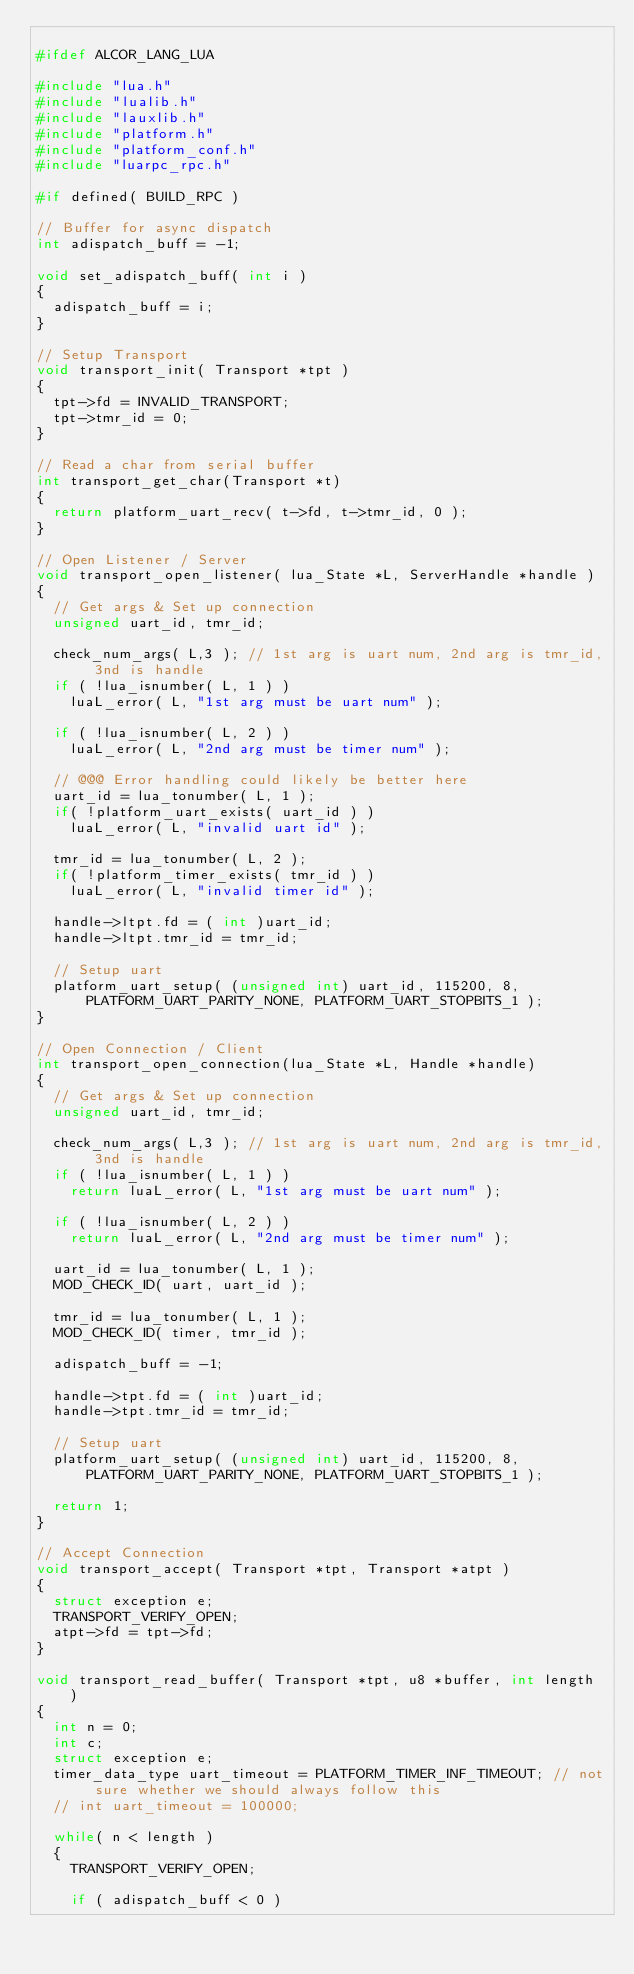Convert code to text. <code><loc_0><loc_0><loc_500><loc_500><_C_>
#ifdef ALCOR_LANG_LUA

#include "lua.h"
#include "lualib.h"
#include "lauxlib.h"
#include "platform.h"
#include "platform_conf.h"
#include "luarpc_rpc.h"

#if defined( BUILD_RPC )

// Buffer for async dispatch
int adispatch_buff = -1;

void set_adispatch_buff( int i )
{
  adispatch_buff = i;
}

// Setup Transport
void transport_init( Transport *tpt )
{
  tpt->fd = INVALID_TRANSPORT;
  tpt->tmr_id = 0;
}

// Read a char from serial buffer
int transport_get_char(Transport *t)
{
  return platform_uart_recv( t->fd, t->tmr_id, 0 );
}

// Open Listener / Server
void transport_open_listener( lua_State *L, ServerHandle *handle )
{
  // Get args & Set up connection
  unsigned uart_id, tmr_id;
  
  check_num_args( L,3 ); // 1st arg is uart num, 2nd arg is tmr_id, 3nd is handle
  if ( !lua_isnumber( L, 1 ) ) 
    luaL_error( L, "1st arg must be uart num" );
    
  if ( !lua_isnumber( L, 2 ) ) 
    luaL_error( L, "2nd arg must be timer num" );

  // @@@ Error handling could likely be better here
  uart_id = lua_tonumber( L, 1 );
  if( !platform_uart_exists( uart_id ) )
    luaL_error( L, "invalid uart id" );
  
  tmr_id = lua_tonumber( L, 2 );
  if( !platform_timer_exists( tmr_id ) )
    luaL_error( L, "invalid timer id" );
  
  handle->ltpt.fd = ( int )uart_id;
  handle->ltpt.tmr_id = tmr_id;

  // Setup uart
  platform_uart_setup( (unsigned int) uart_id, 115200, 8, PLATFORM_UART_PARITY_NONE, PLATFORM_UART_STOPBITS_1 );
}

// Open Connection / Client
int transport_open_connection(lua_State *L, Handle *handle)
{
  // Get args & Set up connection
  unsigned uart_id, tmr_id;
  
  check_num_args( L,3 ); // 1st arg is uart num, 2nd arg is tmr_id, 3nd is handle
  if ( !lua_isnumber( L, 1 ) ) 
    return luaL_error( L, "1st arg must be uart num" );
    
  if ( !lua_isnumber( L, 2 ) ) 
    return luaL_error( L, "2nd arg must be timer num" );

  uart_id = lua_tonumber( L, 1 );
  MOD_CHECK_ID( uart, uart_id );
  
  tmr_id = lua_tonumber( L, 1 );
  MOD_CHECK_ID( timer, tmr_id );
  
  adispatch_buff = -1;

  handle->tpt.fd = ( int )uart_id;
  handle->tpt.tmr_id = tmr_id;

  // Setup uart
  platform_uart_setup( (unsigned int) uart_id, 115200, 8, PLATFORM_UART_PARITY_NONE, PLATFORM_UART_STOPBITS_1 );

  return 1;
}

// Accept Connection 
void transport_accept( Transport *tpt, Transport *atpt )
{
  struct exception e;
  TRANSPORT_VERIFY_OPEN;
  atpt->fd = tpt->fd;
}

void transport_read_buffer( Transport *tpt, u8 *buffer, int length )
{
  int n = 0;
  int c;
  struct exception e;
  timer_data_type uart_timeout = PLATFORM_TIMER_INF_TIMEOUT; // not sure whether we should always follow this
  // int uart_timeout = 100000;
	
  while( n < length )
  {
    TRANSPORT_VERIFY_OPEN;

    if ( adispatch_buff < 0 )</code> 